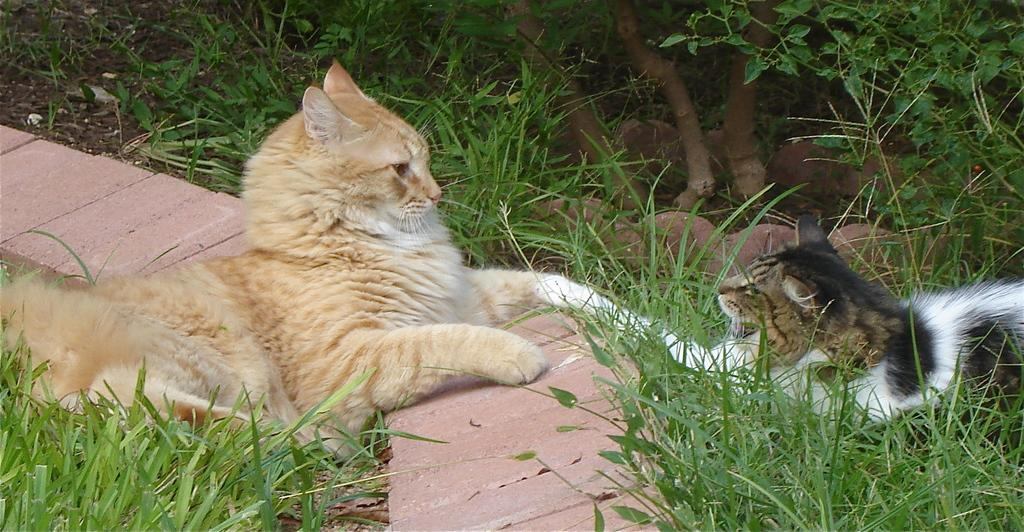How many cats are in the image? There are two cats in the image. What is the surface the cats are on? The cats are on grass. What can be seen in the background of the image? There is a fence and plants in the image. Can you determine the time of day the image was taken? The image is likely taken during the day. Where might this image have been taken? The image may have been taken in a park. What is the representative doing at the protest in the image? There is no representative or protest present in the image; it features two cats on grass with a fence and plants in the background. 